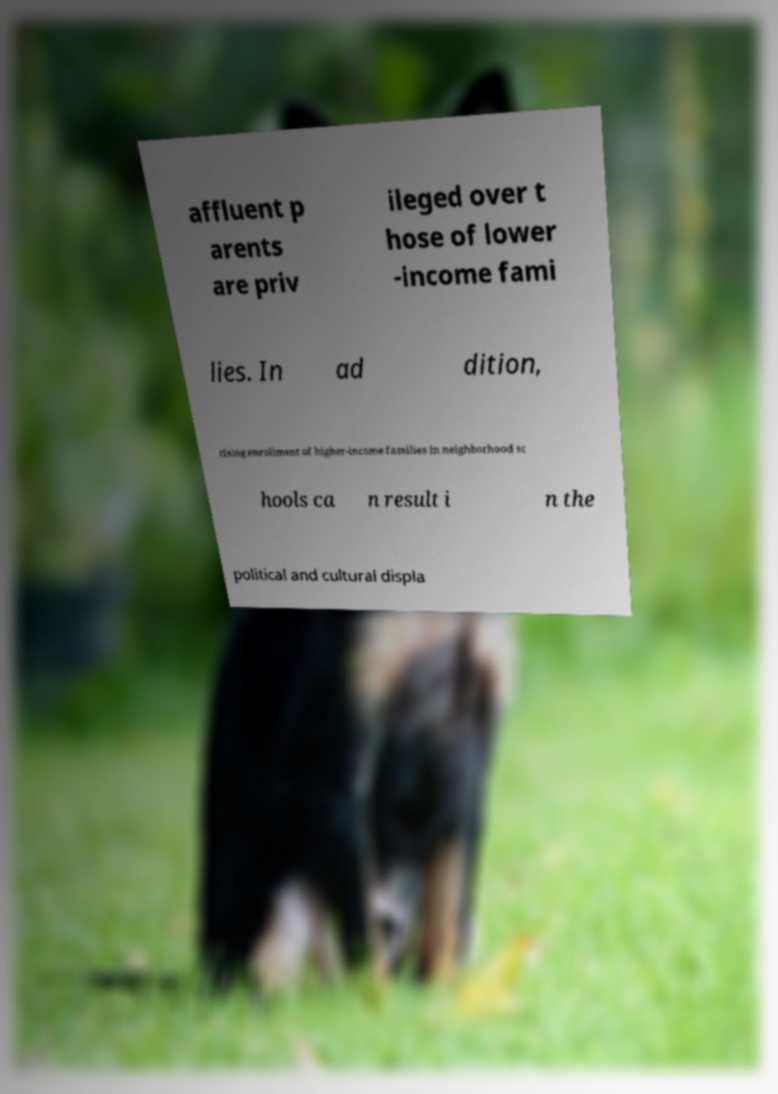Please identify and transcribe the text found in this image. affluent p arents are priv ileged over t hose of lower -income fami lies. In ad dition, rising enrollment of higher-income families in neighborhood sc hools ca n result i n the political and cultural displa 